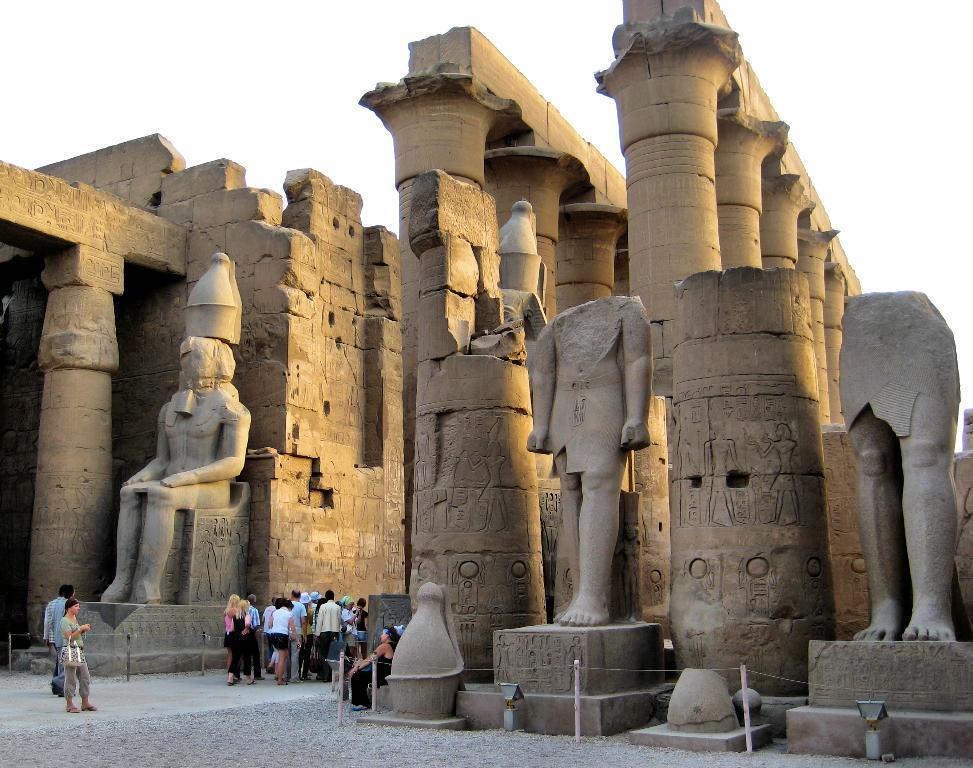Can you describe this image briefly? In this image there are a few people visiting an archaeological site with statues and pillars. 